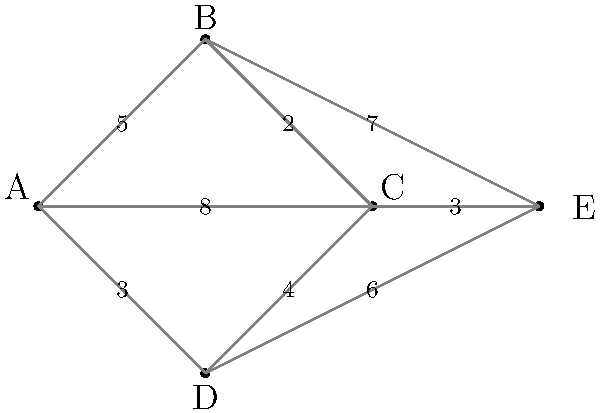As a home healthcare nurse, you need to visit five patients (A, B, C, D, and E) in a single trip. The graph shows the distances (in miles) between each patient's home. What is the shortest route that visits all patients exactly once and returns to the starting point (known as the Traveling Salesman Problem)? To solve this Traveling Salesman Problem, we need to find the shortest Hamiltonian cycle in the graph. Here's a step-by-step approach:

1) First, list all possible Hamiltonian cycles:
   ABCDEA, ABCEDA, ABDCEA, ABDEĆA, ACBDEA, ACBEDA, ACDEBA, ACDEBA, ADCBEA, ADCEBA, ADEBCA, ADEBCA

2) Calculate the total distance for each cycle:
   ABCDEA: 5 + 2 + 4 + 6 + 8 = 25
   ABCEDA: 5 + 2 + 3 + 6 + 8 = 24
   ABDCEA: 5 + 7 + 6 + 4 + 8 = 30
   ABDEĆA: 5 + 7 + 6 + 3 + 8 = 29
   ACBDEA: 8 + 2 + 5 + 3 + 8 = 26
   ACBEDA: 8 + 2 + 7 + 6 + 8 = 31
   ACDEBA: 8 + 4 + 6 + 7 + 8 = 33
   ADCBEA: 3 + 4 + 2 + 7 + 8 = 24
   ADCEBA: 3 + 4 + 3 + 6 + 8 = 24
   ADEBCA: 3 + 6 + 7 + 2 + 8 = 26

3) Identify the cycle(s) with the shortest total distance:
   ABCEDA, ADCBEA, and ADCEBA all have a total distance of 24 miles.

4) Since there are multiple routes with the same shortest distance, any of these can be considered the correct answer.

Therefore, the shortest route is 24 miles long, and can be achieved by following any of these paths: A-B-C-E-D-A, A-D-C-B-E-A, or A-D-C-E-B-A.
Answer: 24 miles (A-B-C-E-D-A, A-D-C-B-E-A, or A-D-C-E-B-A) 